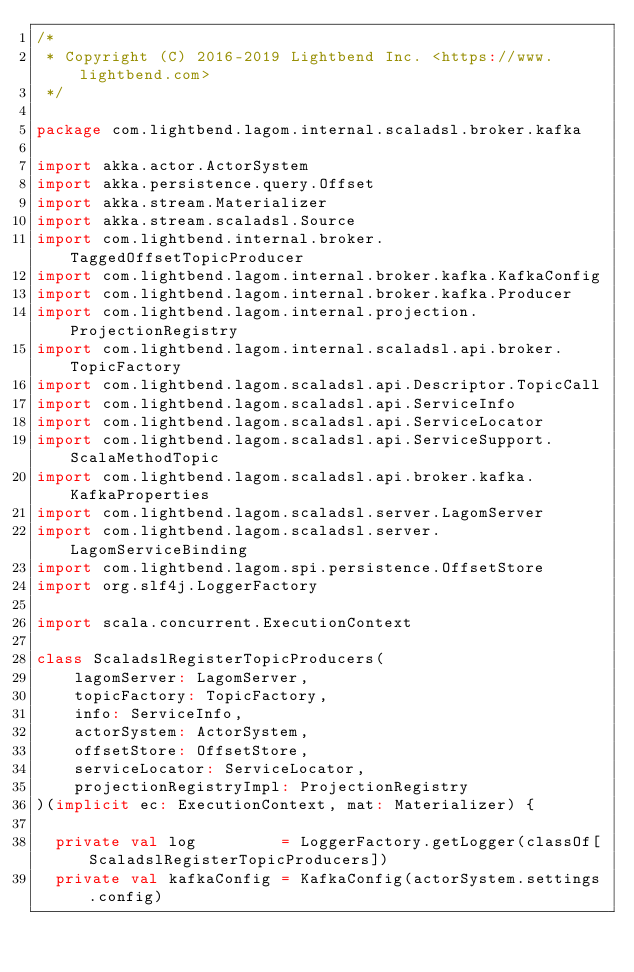Convert code to text. <code><loc_0><loc_0><loc_500><loc_500><_Scala_>/*
 * Copyright (C) 2016-2019 Lightbend Inc. <https://www.lightbend.com>
 */

package com.lightbend.lagom.internal.scaladsl.broker.kafka

import akka.actor.ActorSystem
import akka.persistence.query.Offset
import akka.stream.Materializer
import akka.stream.scaladsl.Source
import com.lightbend.internal.broker.TaggedOffsetTopicProducer
import com.lightbend.lagom.internal.broker.kafka.KafkaConfig
import com.lightbend.lagom.internal.broker.kafka.Producer
import com.lightbend.lagom.internal.projection.ProjectionRegistry
import com.lightbend.lagom.internal.scaladsl.api.broker.TopicFactory
import com.lightbend.lagom.scaladsl.api.Descriptor.TopicCall
import com.lightbend.lagom.scaladsl.api.ServiceInfo
import com.lightbend.lagom.scaladsl.api.ServiceLocator
import com.lightbend.lagom.scaladsl.api.ServiceSupport.ScalaMethodTopic
import com.lightbend.lagom.scaladsl.api.broker.kafka.KafkaProperties
import com.lightbend.lagom.scaladsl.server.LagomServer
import com.lightbend.lagom.scaladsl.server.LagomServiceBinding
import com.lightbend.lagom.spi.persistence.OffsetStore
import org.slf4j.LoggerFactory

import scala.concurrent.ExecutionContext

class ScaladslRegisterTopicProducers(
    lagomServer: LagomServer,
    topicFactory: TopicFactory,
    info: ServiceInfo,
    actorSystem: ActorSystem,
    offsetStore: OffsetStore,
    serviceLocator: ServiceLocator,
    projectionRegistryImpl: ProjectionRegistry
)(implicit ec: ExecutionContext, mat: Materializer) {

  private val log         = LoggerFactory.getLogger(classOf[ScaladslRegisterTopicProducers])
  private val kafkaConfig = KafkaConfig(actorSystem.settings.config)
</code> 